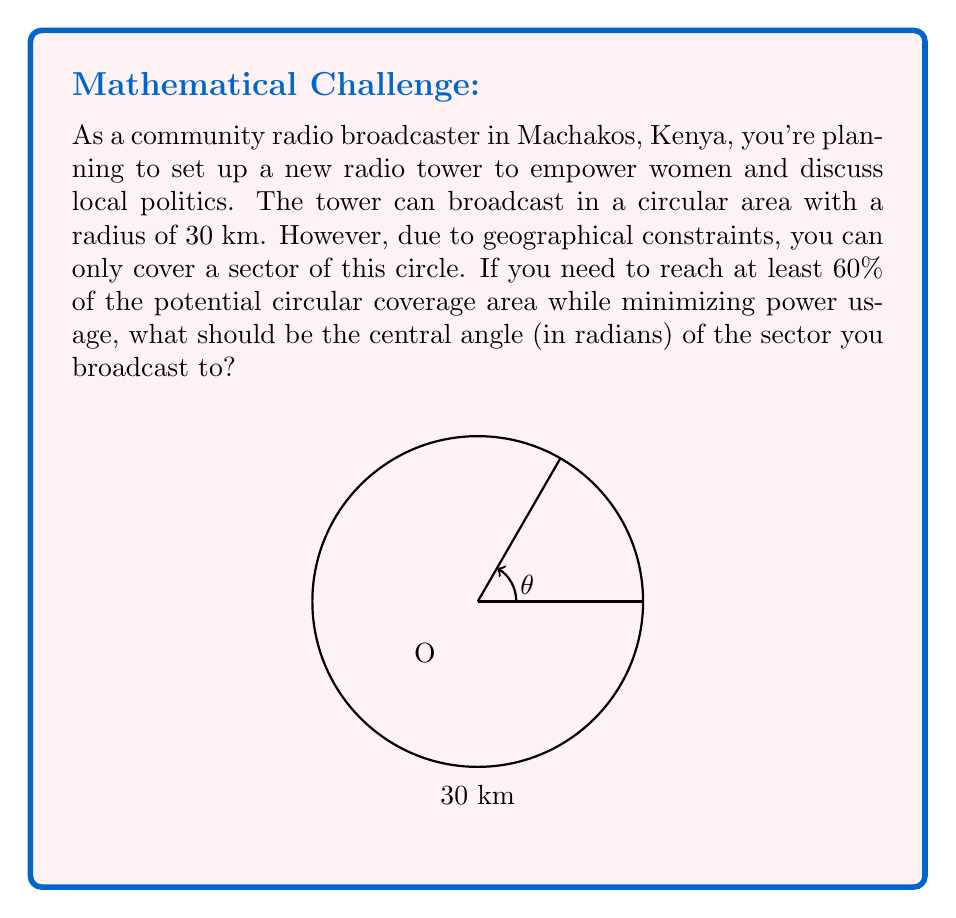Could you help me with this problem? Let's approach this step-by-step:

1) The area of a full circle is given by $A = \pi r^2$. In this case, $r = 30$ km, so the total potential coverage area is:

   $A_{total} = \pi (30)^2 = 900\pi$ km²

2) We need to find a sector that covers at least 60% of this area. Let's call the area of our sector $A_{sector}$. We need:

   $A_{sector} \geq 0.6 * A_{total} = 0.6 * 900\pi = 540\pi$ km²

3) The area of a sector is given by the formula:

   $A_{sector} = \frac{1}{2} r^2 \theta$

   Where $\theta$ is the central angle in radians.

4) Substituting our known values:

   $540\pi = \frac{1}{2} (30)^2 \theta$

5) Simplifying:

   $540\pi = 450\theta$

6) Solving for $\theta$:

   $\theta = \frac{540\pi}{450} = \frac{12\pi}{10} = 1.2\pi$ radians

7) This is the minimum angle needed. To minimize power usage while meeting the coverage requirement, we should use this minimum angle.
Answer: $\frac{12\pi}{10}$ radians 